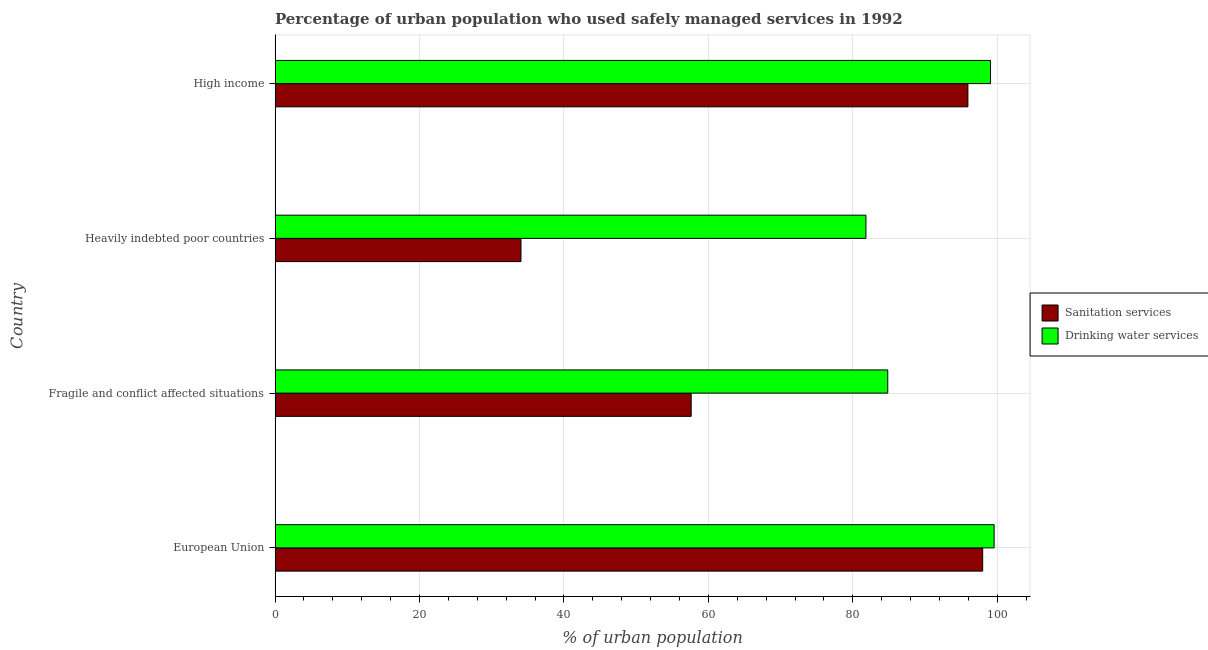How many different coloured bars are there?
Keep it short and to the point. 2. Are the number of bars on each tick of the Y-axis equal?
Your answer should be very brief. Yes. How many bars are there on the 1st tick from the bottom?
Your response must be concise. 2. In how many cases, is the number of bars for a given country not equal to the number of legend labels?
Offer a terse response. 0. What is the percentage of urban population who used drinking water services in European Union?
Your answer should be very brief. 99.56. Across all countries, what is the maximum percentage of urban population who used sanitation services?
Give a very brief answer. 97.98. Across all countries, what is the minimum percentage of urban population who used sanitation services?
Ensure brevity in your answer.  34.05. In which country was the percentage of urban population who used sanitation services maximum?
Provide a short and direct response. European Union. In which country was the percentage of urban population who used drinking water services minimum?
Give a very brief answer. Heavily indebted poor countries. What is the total percentage of urban population who used sanitation services in the graph?
Ensure brevity in your answer.  285.58. What is the difference between the percentage of urban population who used drinking water services in European Union and that in Heavily indebted poor countries?
Offer a terse response. 17.75. What is the difference between the percentage of urban population who used drinking water services in Fragile and conflict affected situations and the percentage of urban population who used sanitation services in European Union?
Keep it short and to the point. -13.14. What is the average percentage of urban population who used sanitation services per country?
Give a very brief answer. 71.4. What is the difference between the percentage of urban population who used sanitation services and percentage of urban population who used drinking water services in High income?
Ensure brevity in your answer.  -3.13. What is the ratio of the percentage of urban population who used drinking water services in Heavily indebted poor countries to that in High income?
Provide a short and direct response. 0.83. Is the percentage of urban population who used sanitation services in Fragile and conflict affected situations less than that in High income?
Keep it short and to the point. Yes. Is the difference between the percentage of urban population who used sanitation services in European Union and Heavily indebted poor countries greater than the difference between the percentage of urban population who used drinking water services in European Union and Heavily indebted poor countries?
Make the answer very short. Yes. What is the difference between the highest and the second highest percentage of urban population who used drinking water services?
Provide a succinct answer. 0.5. What is the difference between the highest and the lowest percentage of urban population who used drinking water services?
Provide a succinct answer. 17.75. What does the 1st bar from the top in Heavily indebted poor countries represents?
Provide a succinct answer. Drinking water services. What does the 2nd bar from the bottom in High income represents?
Offer a very short reply. Drinking water services. How many countries are there in the graph?
Give a very brief answer. 4. Does the graph contain any zero values?
Your answer should be compact. No. Where does the legend appear in the graph?
Offer a terse response. Center right. How many legend labels are there?
Give a very brief answer. 2. What is the title of the graph?
Ensure brevity in your answer.  Percentage of urban population who used safely managed services in 1992. What is the label or title of the X-axis?
Ensure brevity in your answer.  % of urban population. What is the % of urban population of Sanitation services in European Union?
Your response must be concise. 97.98. What is the % of urban population in Drinking water services in European Union?
Provide a short and direct response. 99.56. What is the % of urban population in Sanitation services in Fragile and conflict affected situations?
Keep it short and to the point. 57.62. What is the % of urban population in Drinking water services in Fragile and conflict affected situations?
Offer a very short reply. 84.84. What is the % of urban population in Sanitation services in Heavily indebted poor countries?
Your response must be concise. 34.05. What is the % of urban population in Drinking water services in Heavily indebted poor countries?
Offer a terse response. 81.82. What is the % of urban population in Sanitation services in High income?
Keep it short and to the point. 95.94. What is the % of urban population of Drinking water services in High income?
Offer a terse response. 99.07. Across all countries, what is the maximum % of urban population of Sanitation services?
Your response must be concise. 97.98. Across all countries, what is the maximum % of urban population of Drinking water services?
Keep it short and to the point. 99.56. Across all countries, what is the minimum % of urban population of Sanitation services?
Offer a terse response. 34.05. Across all countries, what is the minimum % of urban population in Drinking water services?
Offer a terse response. 81.82. What is the total % of urban population of Sanitation services in the graph?
Your answer should be compact. 285.58. What is the total % of urban population in Drinking water services in the graph?
Provide a short and direct response. 365.28. What is the difference between the % of urban population in Sanitation services in European Union and that in Fragile and conflict affected situations?
Offer a very short reply. 40.36. What is the difference between the % of urban population of Drinking water services in European Union and that in Fragile and conflict affected situations?
Offer a terse response. 14.73. What is the difference between the % of urban population of Sanitation services in European Union and that in Heavily indebted poor countries?
Ensure brevity in your answer.  63.93. What is the difference between the % of urban population in Drinking water services in European Union and that in Heavily indebted poor countries?
Make the answer very short. 17.75. What is the difference between the % of urban population in Sanitation services in European Union and that in High income?
Offer a terse response. 2.04. What is the difference between the % of urban population in Drinking water services in European Union and that in High income?
Your response must be concise. 0.5. What is the difference between the % of urban population of Sanitation services in Fragile and conflict affected situations and that in Heavily indebted poor countries?
Ensure brevity in your answer.  23.57. What is the difference between the % of urban population of Drinking water services in Fragile and conflict affected situations and that in Heavily indebted poor countries?
Provide a succinct answer. 3.02. What is the difference between the % of urban population of Sanitation services in Fragile and conflict affected situations and that in High income?
Offer a very short reply. -38.32. What is the difference between the % of urban population of Drinking water services in Fragile and conflict affected situations and that in High income?
Provide a short and direct response. -14.23. What is the difference between the % of urban population in Sanitation services in Heavily indebted poor countries and that in High income?
Ensure brevity in your answer.  -61.88. What is the difference between the % of urban population of Drinking water services in Heavily indebted poor countries and that in High income?
Give a very brief answer. -17.25. What is the difference between the % of urban population in Sanitation services in European Union and the % of urban population in Drinking water services in Fragile and conflict affected situations?
Provide a short and direct response. 13.14. What is the difference between the % of urban population in Sanitation services in European Union and the % of urban population in Drinking water services in Heavily indebted poor countries?
Your response must be concise. 16.16. What is the difference between the % of urban population in Sanitation services in European Union and the % of urban population in Drinking water services in High income?
Ensure brevity in your answer.  -1.09. What is the difference between the % of urban population in Sanitation services in Fragile and conflict affected situations and the % of urban population in Drinking water services in Heavily indebted poor countries?
Provide a short and direct response. -24.2. What is the difference between the % of urban population of Sanitation services in Fragile and conflict affected situations and the % of urban population of Drinking water services in High income?
Your answer should be very brief. -41.45. What is the difference between the % of urban population of Sanitation services in Heavily indebted poor countries and the % of urban population of Drinking water services in High income?
Provide a succinct answer. -65.02. What is the average % of urban population in Sanitation services per country?
Offer a terse response. 71.4. What is the average % of urban population of Drinking water services per country?
Offer a terse response. 91.32. What is the difference between the % of urban population of Sanitation services and % of urban population of Drinking water services in European Union?
Make the answer very short. -1.58. What is the difference between the % of urban population of Sanitation services and % of urban population of Drinking water services in Fragile and conflict affected situations?
Offer a terse response. -27.22. What is the difference between the % of urban population of Sanitation services and % of urban population of Drinking water services in Heavily indebted poor countries?
Your response must be concise. -47.76. What is the difference between the % of urban population in Sanitation services and % of urban population in Drinking water services in High income?
Your answer should be compact. -3.13. What is the ratio of the % of urban population in Sanitation services in European Union to that in Fragile and conflict affected situations?
Keep it short and to the point. 1.7. What is the ratio of the % of urban population in Drinking water services in European Union to that in Fragile and conflict affected situations?
Offer a terse response. 1.17. What is the ratio of the % of urban population in Sanitation services in European Union to that in Heavily indebted poor countries?
Make the answer very short. 2.88. What is the ratio of the % of urban population of Drinking water services in European Union to that in Heavily indebted poor countries?
Provide a short and direct response. 1.22. What is the ratio of the % of urban population of Sanitation services in European Union to that in High income?
Make the answer very short. 1.02. What is the ratio of the % of urban population in Drinking water services in European Union to that in High income?
Keep it short and to the point. 1. What is the ratio of the % of urban population of Sanitation services in Fragile and conflict affected situations to that in Heavily indebted poor countries?
Ensure brevity in your answer.  1.69. What is the ratio of the % of urban population in Drinking water services in Fragile and conflict affected situations to that in Heavily indebted poor countries?
Offer a terse response. 1.04. What is the ratio of the % of urban population of Sanitation services in Fragile and conflict affected situations to that in High income?
Give a very brief answer. 0.6. What is the ratio of the % of urban population of Drinking water services in Fragile and conflict affected situations to that in High income?
Keep it short and to the point. 0.86. What is the ratio of the % of urban population of Sanitation services in Heavily indebted poor countries to that in High income?
Ensure brevity in your answer.  0.35. What is the ratio of the % of urban population of Drinking water services in Heavily indebted poor countries to that in High income?
Provide a succinct answer. 0.83. What is the difference between the highest and the second highest % of urban population of Sanitation services?
Provide a short and direct response. 2.04. What is the difference between the highest and the second highest % of urban population in Drinking water services?
Your response must be concise. 0.5. What is the difference between the highest and the lowest % of urban population in Sanitation services?
Make the answer very short. 63.93. What is the difference between the highest and the lowest % of urban population of Drinking water services?
Your answer should be very brief. 17.75. 